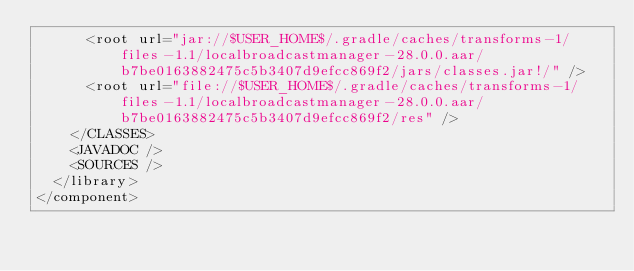Convert code to text. <code><loc_0><loc_0><loc_500><loc_500><_XML_>      <root url="jar://$USER_HOME$/.gradle/caches/transforms-1/files-1.1/localbroadcastmanager-28.0.0.aar/b7be0163882475c5b3407d9efcc869f2/jars/classes.jar!/" />
      <root url="file://$USER_HOME$/.gradle/caches/transforms-1/files-1.1/localbroadcastmanager-28.0.0.aar/b7be0163882475c5b3407d9efcc869f2/res" />
    </CLASSES>
    <JAVADOC />
    <SOURCES />
  </library>
</component></code> 